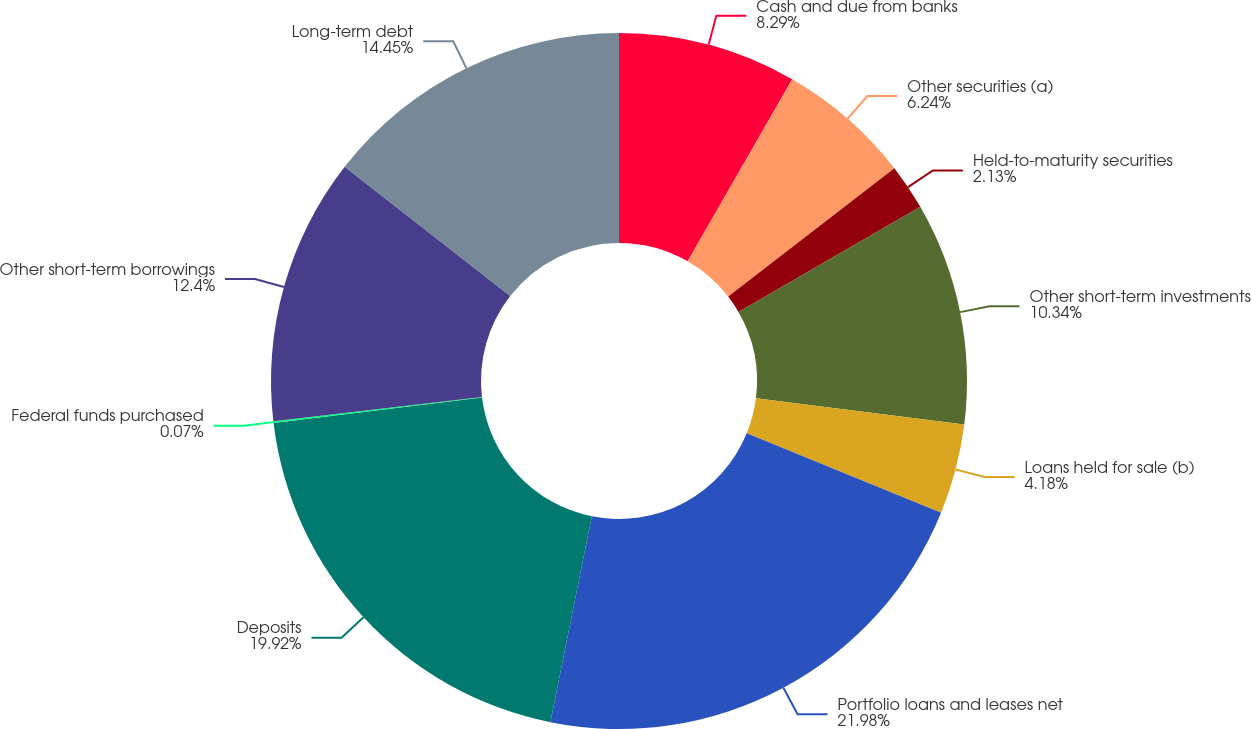Convert chart. <chart><loc_0><loc_0><loc_500><loc_500><pie_chart><fcel>Cash and due from banks<fcel>Other securities (a)<fcel>Held-to-maturity securities<fcel>Other short-term investments<fcel>Loans held for sale (b)<fcel>Portfolio loans and leases net<fcel>Deposits<fcel>Federal funds purchased<fcel>Other short-term borrowings<fcel>Long-term debt<nl><fcel>8.29%<fcel>6.24%<fcel>2.13%<fcel>10.34%<fcel>4.18%<fcel>21.98%<fcel>19.92%<fcel>0.07%<fcel>12.4%<fcel>14.45%<nl></chart> 